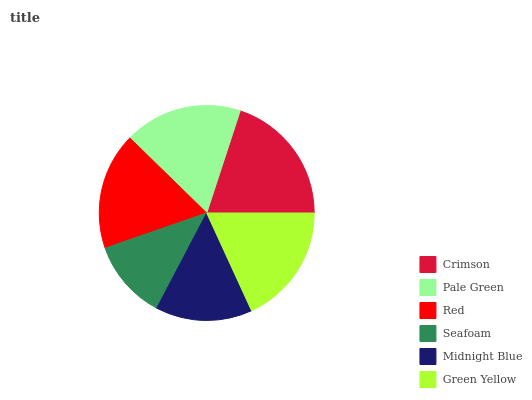Is Seafoam the minimum?
Answer yes or no. Yes. Is Crimson the maximum?
Answer yes or no. Yes. Is Pale Green the minimum?
Answer yes or no. No. Is Pale Green the maximum?
Answer yes or no. No. Is Crimson greater than Pale Green?
Answer yes or no. Yes. Is Pale Green less than Crimson?
Answer yes or no. Yes. Is Pale Green greater than Crimson?
Answer yes or no. No. Is Crimson less than Pale Green?
Answer yes or no. No. Is Pale Green the high median?
Answer yes or no. Yes. Is Red the low median?
Answer yes or no. Yes. Is Crimson the high median?
Answer yes or no. No. Is Crimson the low median?
Answer yes or no. No. 